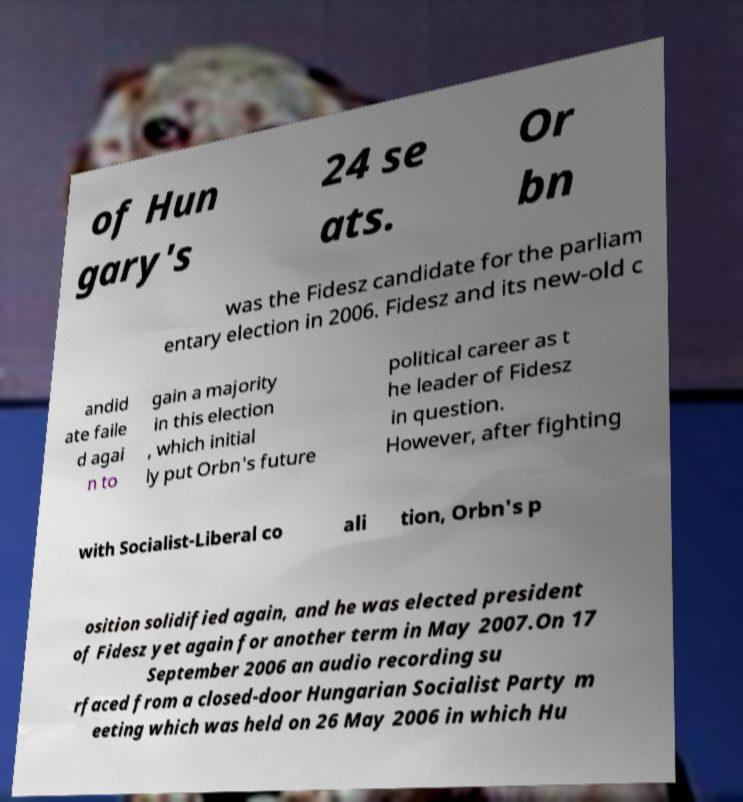I need the written content from this picture converted into text. Can you do that? of Hun gary's 24 se ats. Or bn was the Fidesz candidate for the parliam entary election in 2006. Fidesz and its new-old c andid ate faile d agai n to gain a majority in this election , which initial ly put Orbn's future political career as t he leader of Fidesz in question. However, after fighting with Socialist-Liberal co ali tion, Orbn's p osition solidified again, and he was elected president of Fidesz yet again for another term in May 2007.On 17 September 2006 an audio recording su rfaced from a closed-door Hungarian Socialist Party m eeting which was held on 26 May 2006 in which Hu 